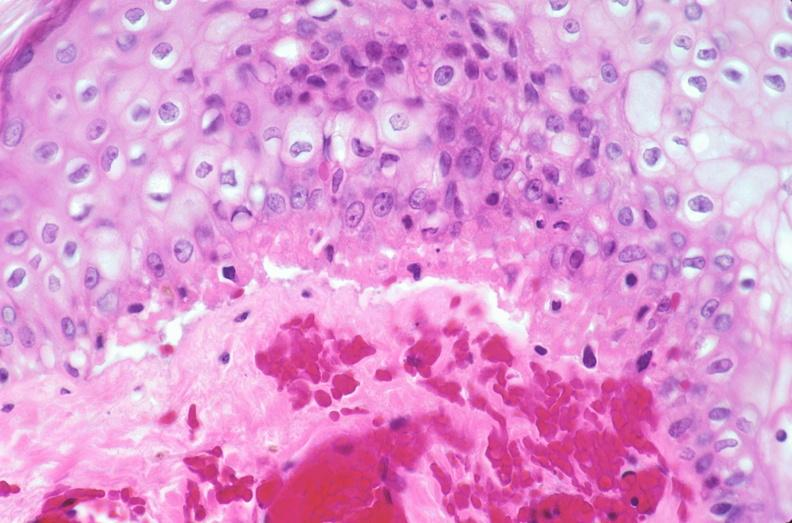where is this?
Answer the question using a single word or phrase. Skin 